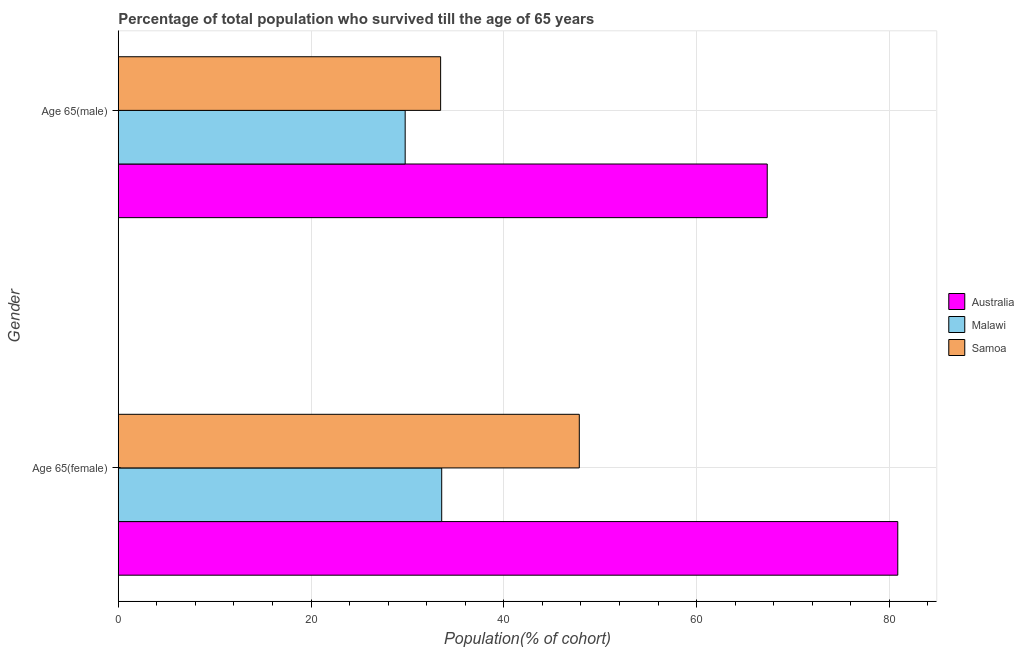How many bars are there on the 2nd tick from the top?
Give a very brief answer. 3. What is the label of the 2nd group of bars from the top?
Make the answer very short. Age 65(female). What is the percentage of male population who survived till age of 65 in Malawi?
Provide a short and direct response. 29.77. Across all countries, what is the maximum percentage of male population who survived till age of 65?
Give a very brief answer. 67.33. Across all countries, what is the minimum percentage of female population who survived till age of 65?
Provide a short and direct response. 33.56. In which country was the percentage of female population who survived till age of 65 minimum?
Your answer should be compact. Malawi. What is the total percentage of female population who survived till age of 65 in the graph?
Ensure brevity in your answer.  162.26. What is the difference between the percentage of male population who survived till age of 65 in Australia and that in Malawi?
Provide a succinct answer. 37.57. What is the difference between the percentage of female population who survived till age of 65 in Australia and the percentage of male population who survived till age of 65 in Malawi?
Your answer should be compact. 51.11. What is the average percentage of male population who survived till age of 65 per country?
Your answer should be very brief. 43.51. What is the difference between the percentage of male population who survived till age of 65 and percentage of female population who survived till age of 65 in Australia?
Ensure brevity in your answer.  -13.54. What is the ratio of the percentage of female population who survived till age of 65 in Malawi to that in Samoa?
Your answer should be compact. 0.7. Is the percentage of male population who survived till age of 65 in Samoa less than that in Malawi?
Give a very brief answer. No. What does the 1st bar from the top in Age 65(male) represents?
Your response must be concise. Samoa. What does the 1st bar from the bottom in Age 65(female) represents?
Your answer should be very brief. Australia. What is the difference between two consecutive major ticks on the X-axis?
Provide a succinct answer. 20. Are the values on the major ticks of X-axis written in scientific E-notation?
Keep it short and to the point. No. Does the graph contain any zero values?
Give a very brief answer. No. Does the graph contain grids?
Give a very brief answer. Yes. Where does the legend appear in the graph?
Provide a succinct answer. Center right. How many legend labels are there?
Ensure brevity in your answer.  3. How are the legend labels stacked?
Ensure brevity in your answer.  Vertical. What is the title of the graph?
Your response must be concise. Percentage of total population who survived till the age of 65 years. What is the label or title of the X-axis?
Offer a very short reply. Population(% of cohort). What is the label or title of the Y-axis?
Your response must be concise. Gender. What is the Population(% of cohort) of Australia in Age 65(female)?
Your answer should be very brief. 80.88. What is the Population(% of cohort) in Malawi in Age 65(female)?
Your response must be concise. 33.56. What is the Population(% of cohort) of Samoa in Age 65(female)?
Provide a short and direct response. 47.83. What is the Population(% of cohort) in Australia in Age 65(male)?
Offer a very short reply. 67.33. What is the Population(% of cohort) of Malawi in Age 65(male)?
Offer a very short reply. 29.77. What is the Population(% of cohort) of Samoa in Age 65(male)?
Offer a terse response. 33.44. Across all Gender, what is the maximum Population(% of cohort) of Australia?
Your response must be concise. 80.88. Across all Gender, what is the maximum Population(% of cohort) in Malawi?
Offer a very short reply. 33.56. Across all Gender, what is the maximum Population(% of cohort) of Samoa?
Ensure brevity in your answer.  47.83. Across all Gender, what is the minimum Population(% of cohort) in Australia?
Ensure brevity in your answer.  67.33. Across all Gender, what is the minimum Population(% of cohort) of Malawi?
Ensure brevity in your answer.  29.77. Across all Gender, what is the minimum Population(% of cohort) in Samoa?
Offer a very short reply. 33.44. What is the total Population(% of cohort) of Australia in the graph?
Provide a short and direct response. 148.21. What is the total Population(% of cohort) of Malawi in the graph?
Your answer should be very brief. 63.32. What is the total Population(% of cohort) in Samoa in the graph?
Ensure brevity in your answer.  81.28. What is the difference between the Population(% of cohort) of Australia in Age 65(female) and that in Age 65(male)?
Offer a terse response. 13.54. What is the difference between the Population(% of cohort) of Malawi in Age 65(female) and that in Age 65(male)?
Provide a short and direct response. 3.79. What is the difference between the Population(% of cohort) in Samoa in Age 65(female) and that in Age 65(male)?
Your response must be concise. 14.39. What is the difference between the Population(% of cohort) of Australia in Age 65(female) and the Population(% of cohort) of Malawi in Age 65(male)?
Your response must be concise. 51.11. What is the difference between the Population(% of cohort) of Australia in Age 65(female) and the Population(% of cohort) of Samoa in Age 65(male)?
Give a very brief answer. 47.43. What is the difference between the Population(% of cohort) of Malawi in Age 65(female) and the Population(% of cohort) of Samoa in Age 65(male)?
Your answer should be very brief. 0.11. What is the average Population(% of cohort) in Australia per Gender?
Your answer should be compact. 74.1. What is the average Population(% of cohort) of Malawi per Gender?
Keep it short and to the point. 31.66. What is the average Population(% of cohort) of Samoa per Gender?
Offer a terse response. 40.64. What is the difference between the Population(% of cohort) in Australia and Population(% of cohort) in Malawi in Age 65(female)?
Keep it short and to the point. 47.32. What is the difference between the Population(% of cohort) in Australia and Population(% of cohort) in Samoa in Age 65(female)?
Offer a very short reply. 33.04. What is the difference between the Population(% of cohort) in Malawi and Population(% of cohort) in Samoa in Age 65(female)?
Keep it short and to the point. -14.28. What is the difference between the Population(% of cohort) in Australia and Population(% of cohort) in Malawi in Age 65(male)?
Your answer should be compact. 37.57. What is the difference between the Population(% of cohort) in Australia and Population(% of cohort) in Samoa in Age 65(male)?
Offer a terse response. 33.89. What is the difference between the Population(% of cohort) in Malawi and Population(% of cohort) in Samoa in Age 65(male)?
Your answer should be very brief. -3.68. What is the ratio of the Population(% of cohort) in Australia in Age 65(female) to that in Age 65(male)?
Provide a succinct answer. 1.2. What is the ratio of the Population(% of cohort) of Malawi in Age 65(female) to that in Age 65(male)?
Make the answer very short. 1.13. What is the ratio of the Population(% of cohort) in Samoa in Age 65(female) to that in Age 65(male)?
Give a very brief answer. 1.43. What is the difference between the highest and the second highest Population(% of cohort) of Australia?
Your answer should be very brief. 13.54. What is the difference between the highest and the second highest Population(% of cohort) in Malawi?
Your answer should be very brief. 3.79. What is the difference between the highest and the second highest Population(% of cohort) of Samoa?
Keep it short and to the point. 14.39. What is the difference between the highest and the lowest Population(% of cohort) in Australia?
Ensure brevity in your answer.  13.54. What is the difference between the highest and the lowest Population(% of cohort) in Malawi?
Provide a short and direct response. 3.79. What is the difference between the highest and the lowest Population(% of cohort) of Samoa?
Your response must be concise. 14.39. 